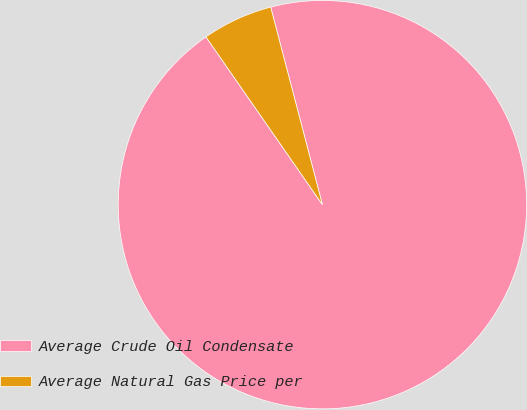<chart> <loc_0><loc_0><loc_500><loc_500><pie_chart><fcel>Average Crude Oil Condensate<fcel>Average Natural Gas Price per<nl><fcel>94.42%<fcel>5.58%<nl></chart> 